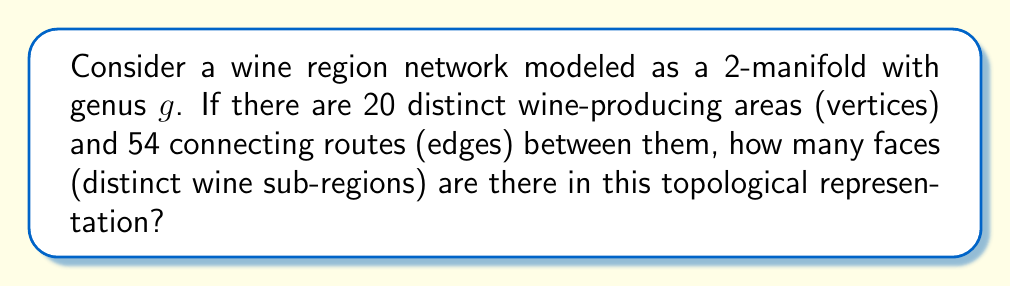Give your solution to this math problem. To solve this problem, we'll use the Euler characteristic formula for a 2-manifold:

$$\chi = V - E + F = 2 - 2g$$

Where:
$\chi$ is the Euler characteristic
$V$ is the number of vertices (wine-producing areas)
$E$ is the number of edges (connecting routes)
$F$ is the number of faces (wine sub-regions)
$g$ is the genus of the manifold

Steps:
1. We're given $V = 20$ and $E = 54$.
2. We need to find $F$.
3. The genus $g$ is not specified, so we'll keep it as a variable.
4. Substitute the known values into the Euler characteristic formula:

   $$20 - 54 + F = 2 - 2g$$

5. Solve for $F$:

   $$F = 2 - 2g - 20 + 54$$
   $$F = 36 - 2g$$

6. Since we're dealing with a real wine region network, $F$ must be a positive integer. The smallest possible value for $g$ that satisfies this condition is 0, which would represent a sphere-like topology.

7. With $g = 0$:

   $$F = 36 - 2(0) = 36$$

Therefore, there are 36 distinct wine sub-regions in this topological representation.
Answer: 36 